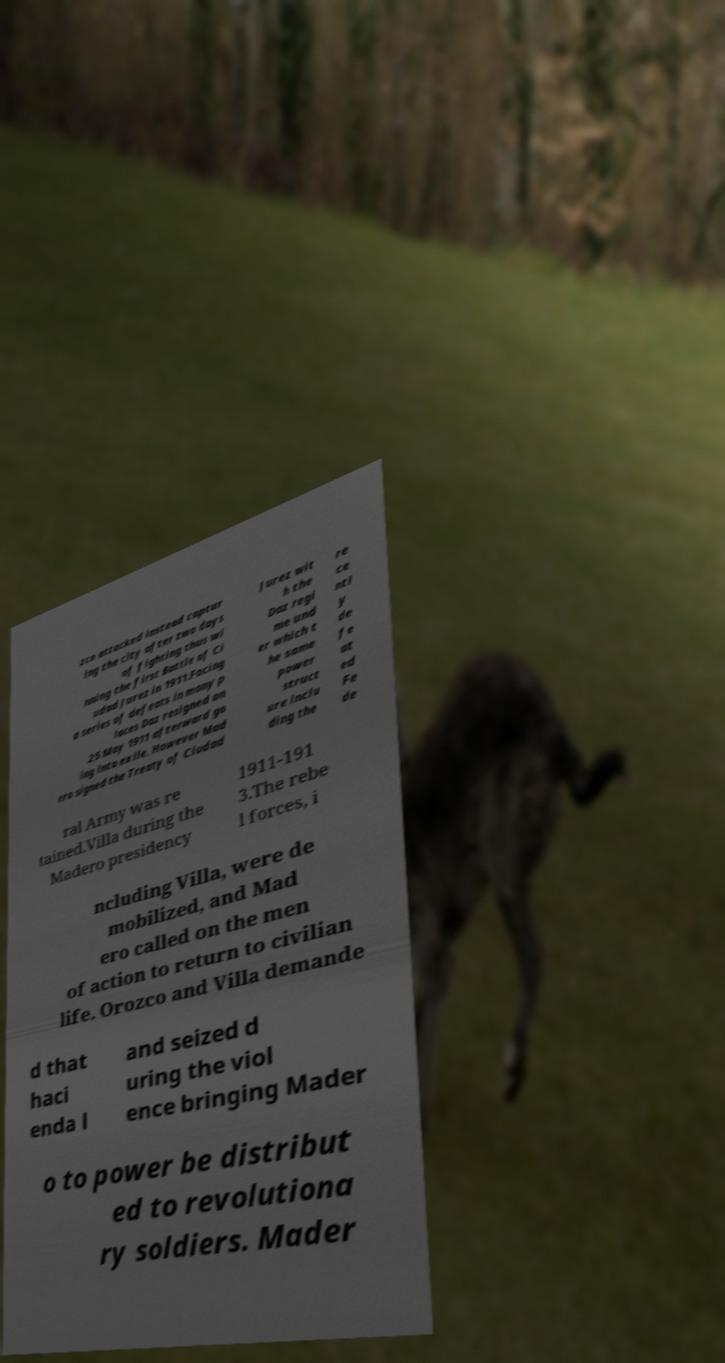Please read and relay the text visible in this image. What does it say? zco attacked instead captur ing the city after two days of fighting thus wi nning the first Battle of Ci udad Jurez in 1911.Facing a series of defeats in many p laces Daz resigned on 25 May 1911 afterward go ing into exile. However Mad ero signed the Treaty of Ciudad Jurez wit h the Daz regi me und er which t he same power struct ure inclu ding the re ce ntl y de fe at ed Fe de ral Army was re tained.Villa during the Madero presidency 1911-191 3.The rebe l forces, i ncluding Villa, were de mobilized, and Mad ero called on the men of action to return to civilian life. Orozco and Villa demande d that haci enda l and seized d uring the viol ence bringing Mader o to power be distribut ed to revolutiona ry soldiers. Mader 